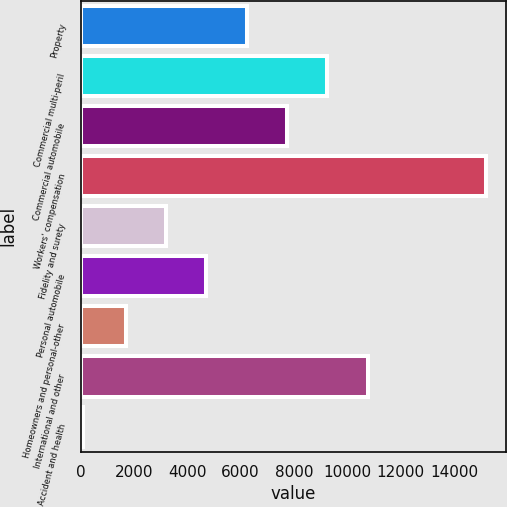<chart> <loc_0><loc_0><loc_500><loc_500><bar_chart><fcel>Property<fcel>Commercial multi-peril<fcel>Commercial automobile<fcel>Workers' compensation<fcel>Fidelity and surety<fcel>Personal automobile<fcel>Homeowners and personal-other<fcel>International and other<fcel>Accident and health<nl><fcel>6228.1<fcel>9249.5<fcel>7738.8<fcel>15190<fcel>3206.7<fcel>4717.4<fcel>1696<fcel>10760.2<fcel>83<nl></chart> 